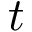Convert formula to latex. <formula><loc_0><loc_0><loc_500><loc_500>t</formula> 